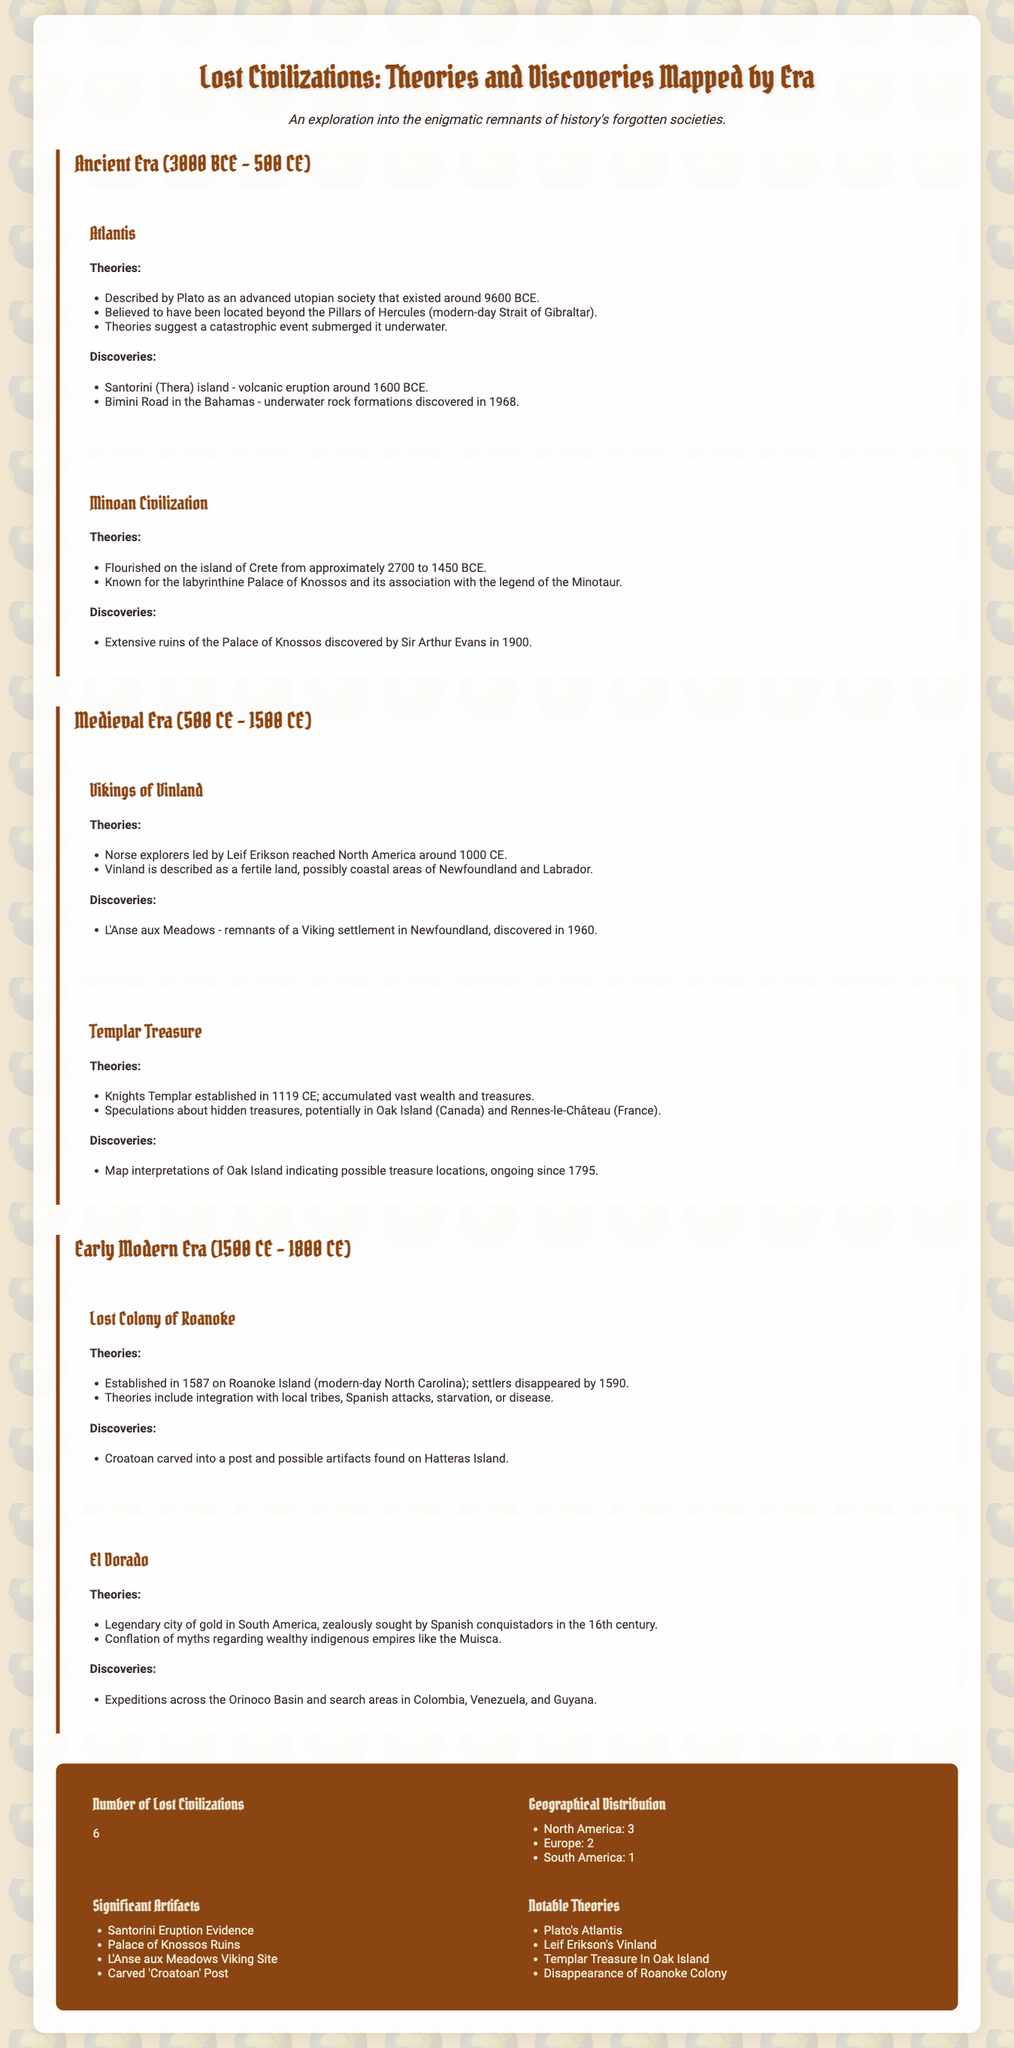what is the total number of lost civilizations mentioned? The document states there are 6 lost civilizations listed under the stats section.
Answer: 6 which civilization is associated with the legend of the Minotaur? The Minoan Civilization is tied to the legend of the Minotaur, as detailed in the Ancient Era section.
Answer: Minoan Civilization when did the settlers of the Lost Colony of Roanoke disappear? The document notes that the settlers vanished by 1590 after establishing the colony in 1587.
Answer: 1590 what is one significant artifact discovered related to the Minoan Civilization? The Palace of Knossos ruins are highlighted as significant artifacts, found through archaeological efforts.
Answer: Palace of Knossos Ruins where is the Viking settlement L'Anse aux Meadows located? It is stated that L'Anse aux Meadows is in Newfoundland and was discovered in 1960, emphasizing its geographical significance.
Answer: Newfoundland what catastrophic event is believed to have submerged Atlantis? Theories suggest that a catastrophic event led to Atlantis being submerged underwater, as mentioned in the Ancient Era.
Answer: Catastrophic event who were the explorers that reached North America around 1000 CE? Leif Erikson led the Norse explorers to North America, as described in the Medieval Era section.
Answer: Leif Erikson which civilization's theories are linked to hidden treasures in Oak Island? The Templar Treasure theories speculated about hidden treasures in locations like Oak Island, as explored in the Medieval Era.
Answer: Templar Treasure 